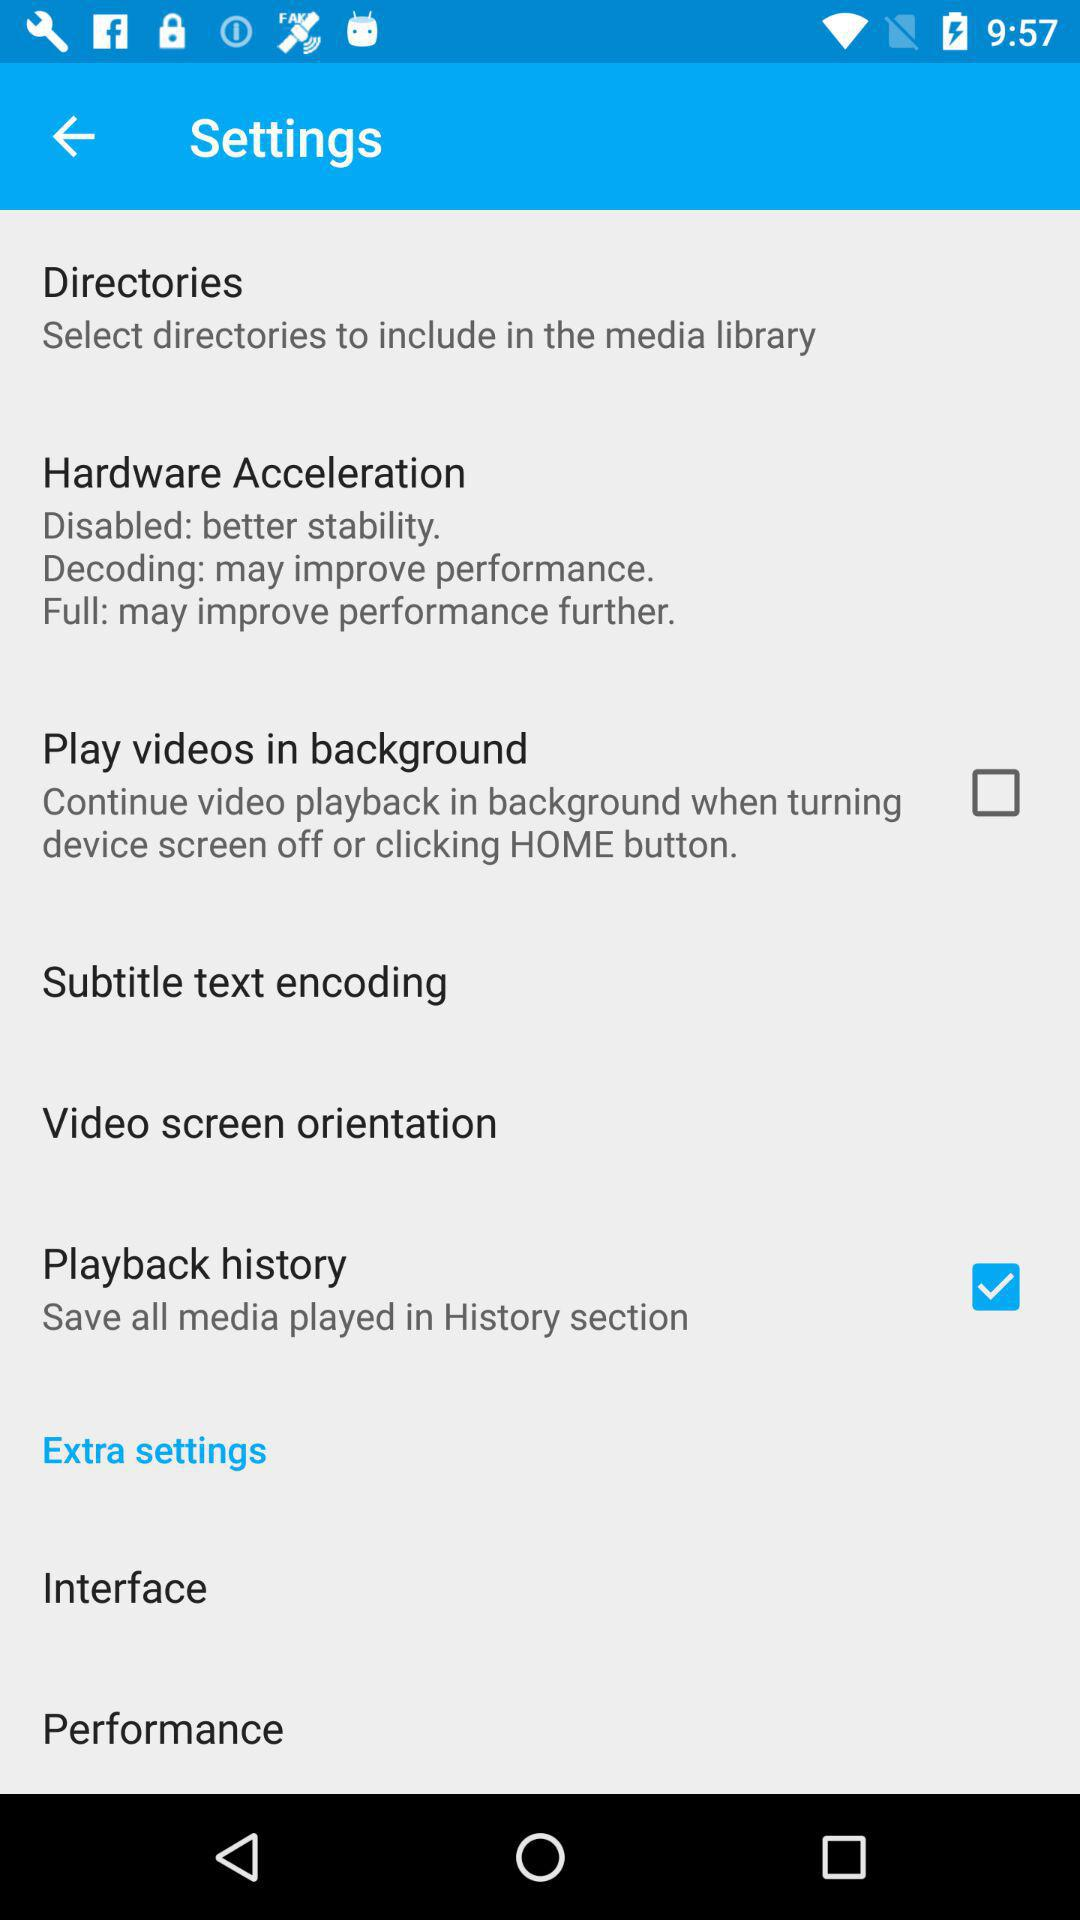What's the status of "Flat"? The status is "off". 